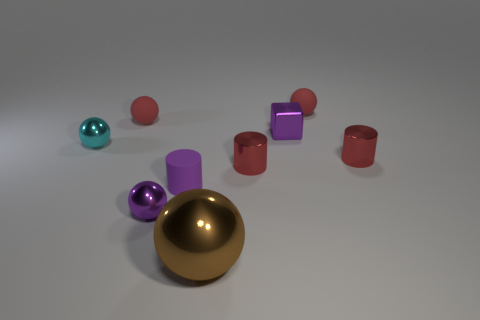Subtract all purple cylinders. How many cylinders are left? 2 Subtract all shiny balls. How many balls are left? 2 Subtract all brown cubes. How many blue balls are left? 0 Subtract all objects. Subtract all big yellow shiny cylinders. How many objects are left? 0 Add 8 tiny red metallic cylinders. How many tiny red metallic cylinders are left? 10 Add 2 brown rubber cylinders. How many brown rubber cylinders exist? 2 Subtract 0 green spheres. How many objects are left? 9 Subtract all cylinders. How many objects are left? 6 Subtract 2 balls. How many balls are left? 3 Subtract all green cylinders. Subtract all red balls. How many cylinders are left? 3 